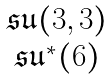<formula> <loc_0><loc_0><loc_500><loc_500>\begin{matrix} { \mathfrak { s u } } ( 3 , 3 ) \\ { \mathfrak { s u } } ^ { \ast } ( 6 ) \end{matrix}</formula> 